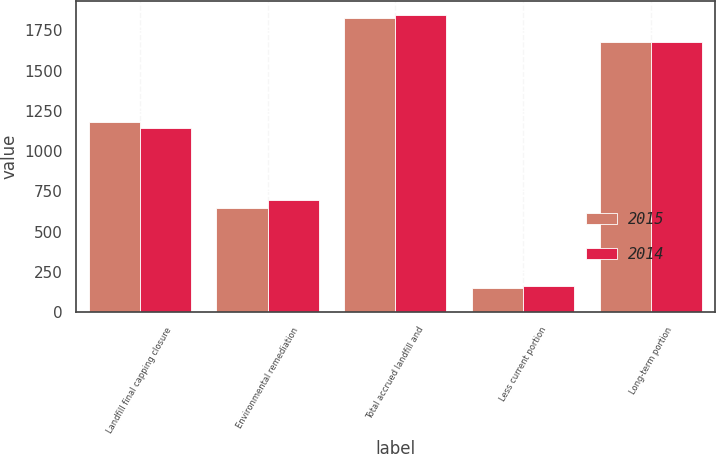<chart> <loc_0><loc_0><loc_500><loc_500><stacked_bar_chart><ecel><fcel>Landfill final capping closure<fcel>Environmental remediation<fcel>Total accrued landfill and<fcel>Less current portion<fcel>Long-term portion<nl><fcel>2015<fcel>1181.6<fcel>646.1<fcel>1827.7<fcel>149.8<fcel>1677.9<nl><fcel>2014<fcel>1144.3<fcel>697.5<fcel>1841.8<fcel>164.3<fcel>1677.5<nl></chart> 